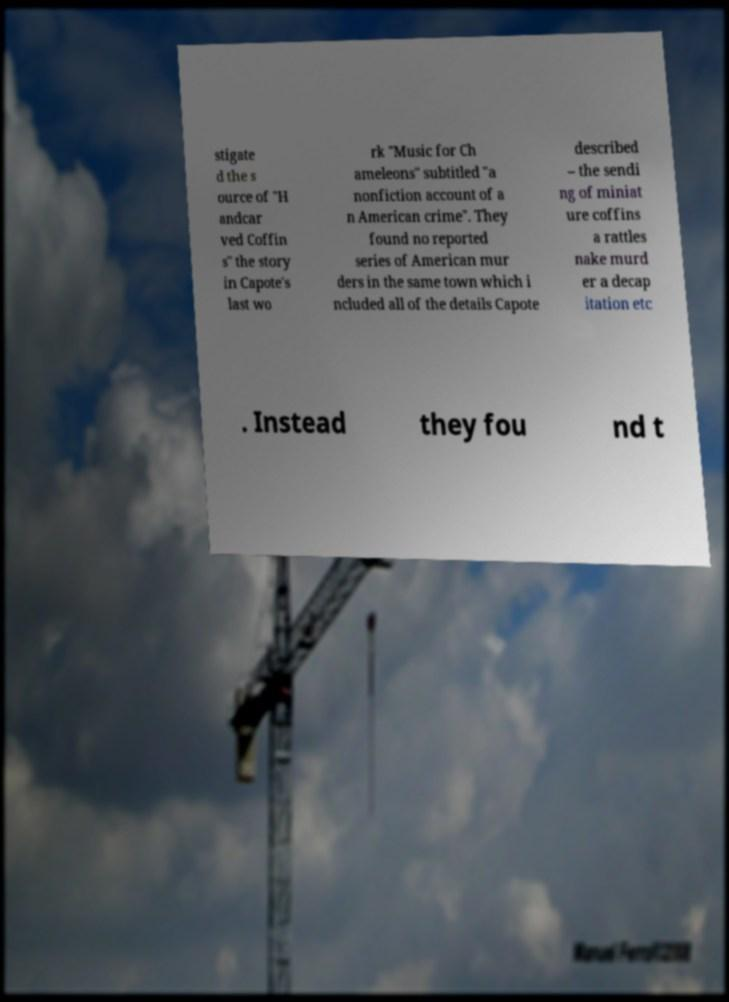For documentation purposes, I need the text within this image transcribed. Could you provide that? stigate d the s ource of "H andcar ved Coffin s" the story in Capote's last wo rk "Music for Ch ameleons" subtitled "a nonfiction account of a n American crime". They found no reported series of American mur ders in the same town which i ncluded all of the details Capote described – the sendi ng of miniat ure coffins a rattles nake murd er a decap itation etc . Instead they fou nd t 